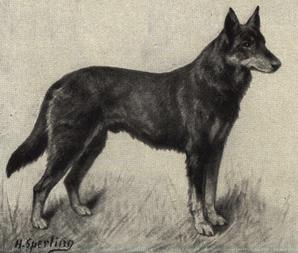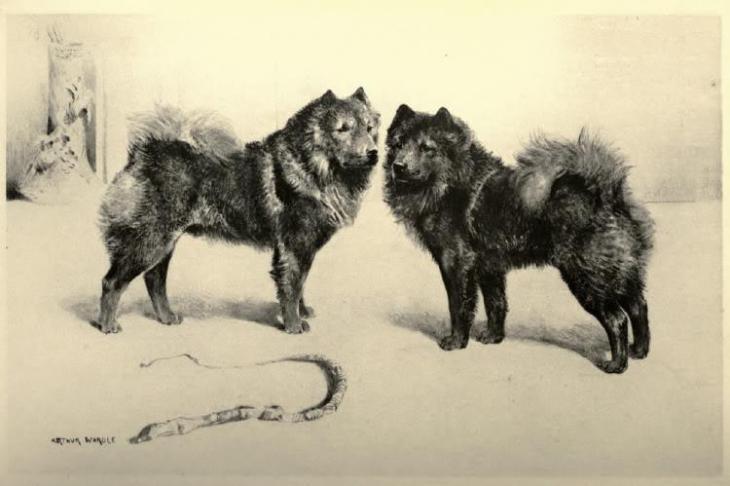The first image is the image on the left, the second image is the image on the right. Considering the images on both sides, is "The dog in one of the images is lying down." valid? Answer yes or no. No. The first image is the image on the left, the second image is the image on the right. Analyze the images presented: Is the assertion "Each image contains one solid black dog, and all dogs have their bodies turned rightward." valid? Answer yes or no. No. 